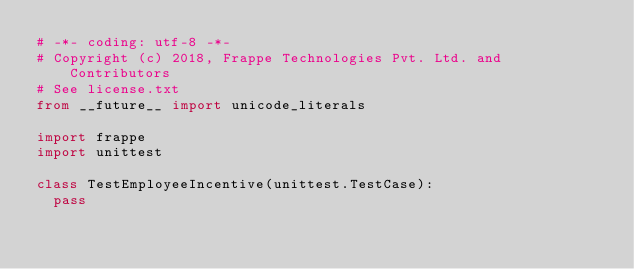<code> <loc_0><loc_0><loc_500><loc_500><_Python_># -*- coding: utf-8 -*-
# Copyright (c) 2018, Frappe Technologies Pvt. Ltd. and Contributors
# See license.txt
from __future__ import unicode_literals

import frappe
import unittest

class TestEmployeeIncentive(unittest.TestCase):
	pass
</code> 